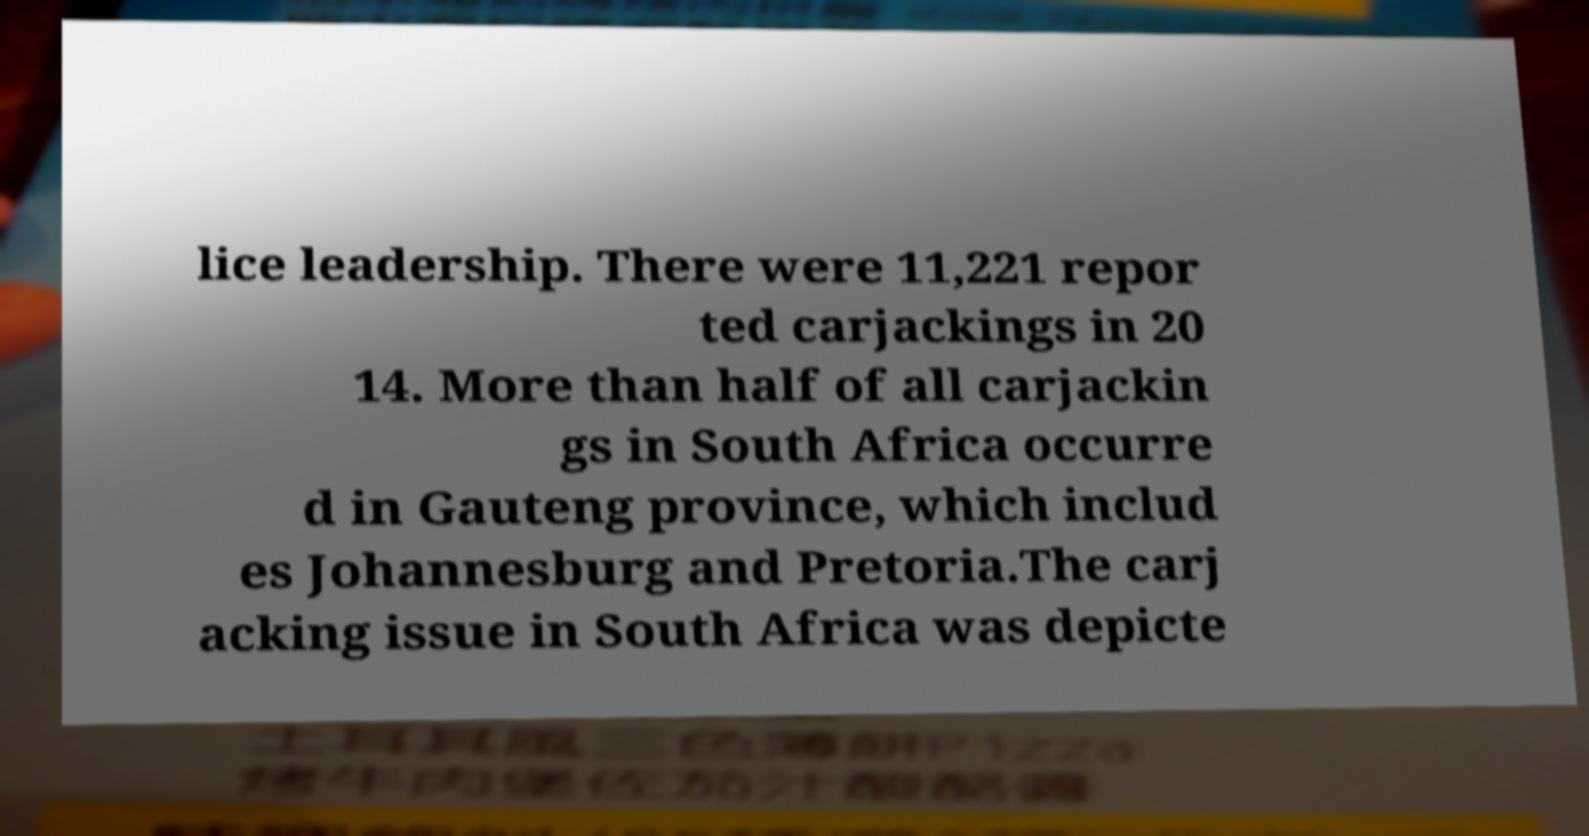For documentation purposes, I need the text within this image transcribed. Could you provide that? lice leadership. There were 11,221 repor ted carjackings in 20 14. More than half of all carjackin gs in South Africa occurre d in Gauteng province, which includ es Johannesburg and Pretoria.The carj acking issue in South Africa was depicte 